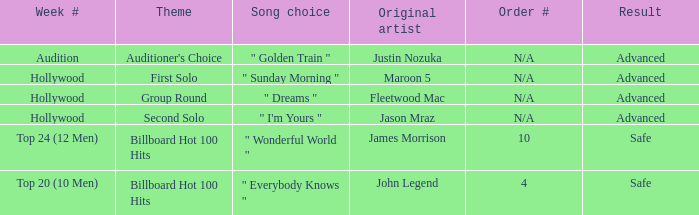In which areas can "golden train" be considered a preferred music choice? Auditioner's Choice. 